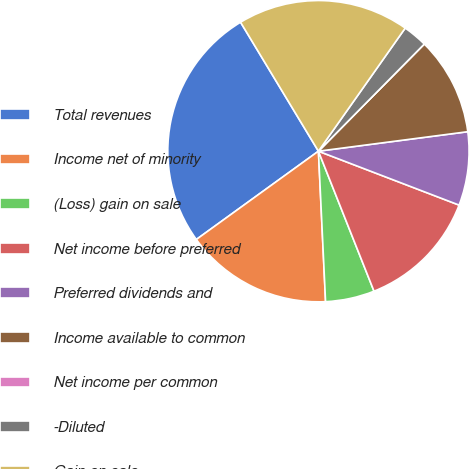Convert chart. <chart><loc_0><loc_0><loc_500><loc_500><pie_chart><fcel>Total revenues<fcel>Income net of minority<fcel>(Loss) gain on sale<fcel>Net income before preferred<fcel>Preferred dividends and<fcel>Income available to common<fcel>Net income per common<fcel>-Diluted<fcel>Gain on sale<nl><fcel>26.32%<fcel>15.79%<fcel>5.26%<fcel>13.16%<fcel>7.89%<fcel>10.53%<fcel>0.0%<fcel>2.63%<fcel>18.42%<nl></chart> 